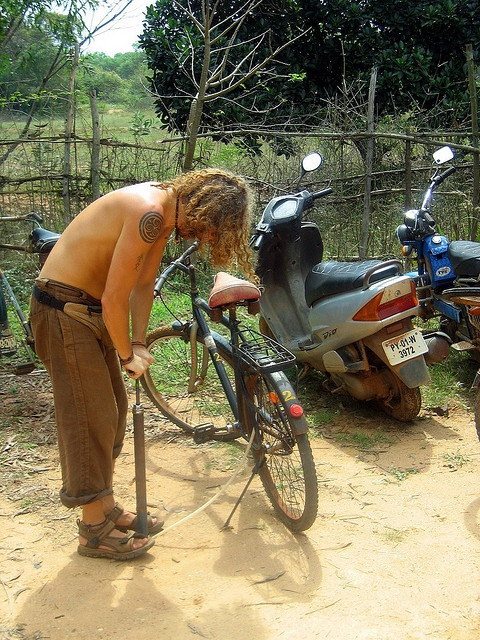Describe the objects in this image and their specific colors. I can see people in darkgreen, maroon, brown, and tan tones, bicycle in darkgreen, black, olive, and gray tones, motorcycle in darkgreen, black, gray, and maroon tones, motorcycle in darkgreen, black, gray, navy, and white tones, and bicycle in darkgreen, black, gray, and darkgray tones in this image. 